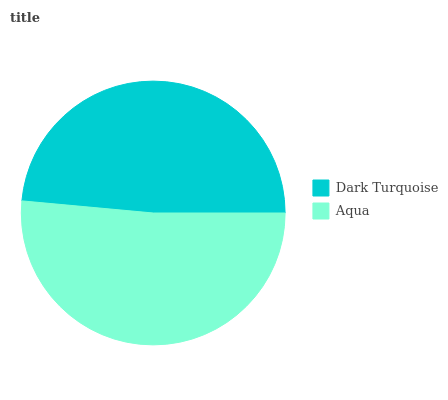Is Dark Turquoise the minimum?
Answer yes or no. Yes. Is Aqua the maximum?
Answer yes or no. Yes. Is Aqua the minimum?
Answer yes or no. No. Is Aqua greater than Dark Turquoise?
Answer yes or no. Yes. Is Dark Turquoise less than Aqua?
Answer yes or no. Yes. Is Dark Turquoise greater than Aqua?
Answer yes or no. No. Is Aqua less than Dark Turquoise?
Answer yes or no. No. Is Aqua the high median?
Answer yes or no. Yes. Is Dark Turquoise the low median?
Answer yes or no. Yes. Is Dark Turquoise the high median?
Answer yes or no. No. Is Aqua the low median?
Answer yes or no. No. 